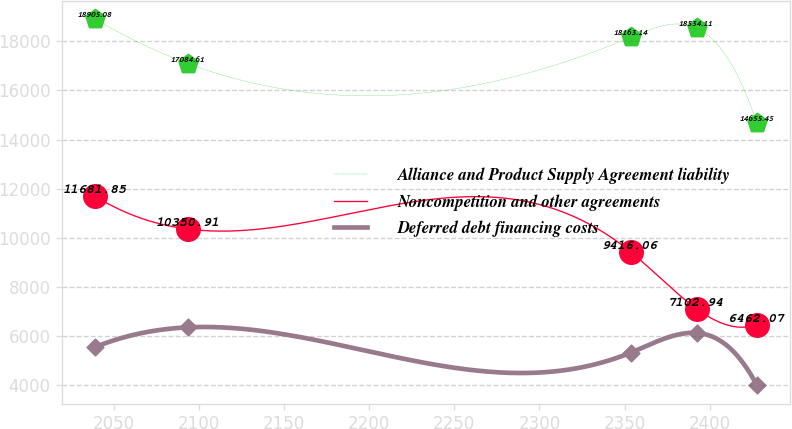<chart> <loc_0><loc_0><loc_500><loc_500><line_chart><ecel><fcel>Alliance and Product Supply Agreement liability<fcel>Noncompetition and other agreements<fcel>Deferred debt financing costs<nl><fcel>2039.29<fcel>18905.1<fcel>11681.9<fcel>5550.9<nl><fcel>2093.95<fcel>17084.6<fcel>10350.9<fcel>6350.65<nl><fcel>2353.71<fcel>18163.1<fcel>9416.06<fcel>5321.86<nl><fcel>2392.34<fcel>18534.1<fcel>7102.94<fcel>6121.61<nl><fcel>2427.75<fcel>14655.5<fcel>6462.07<fcel>3982.91<nl></chart> 